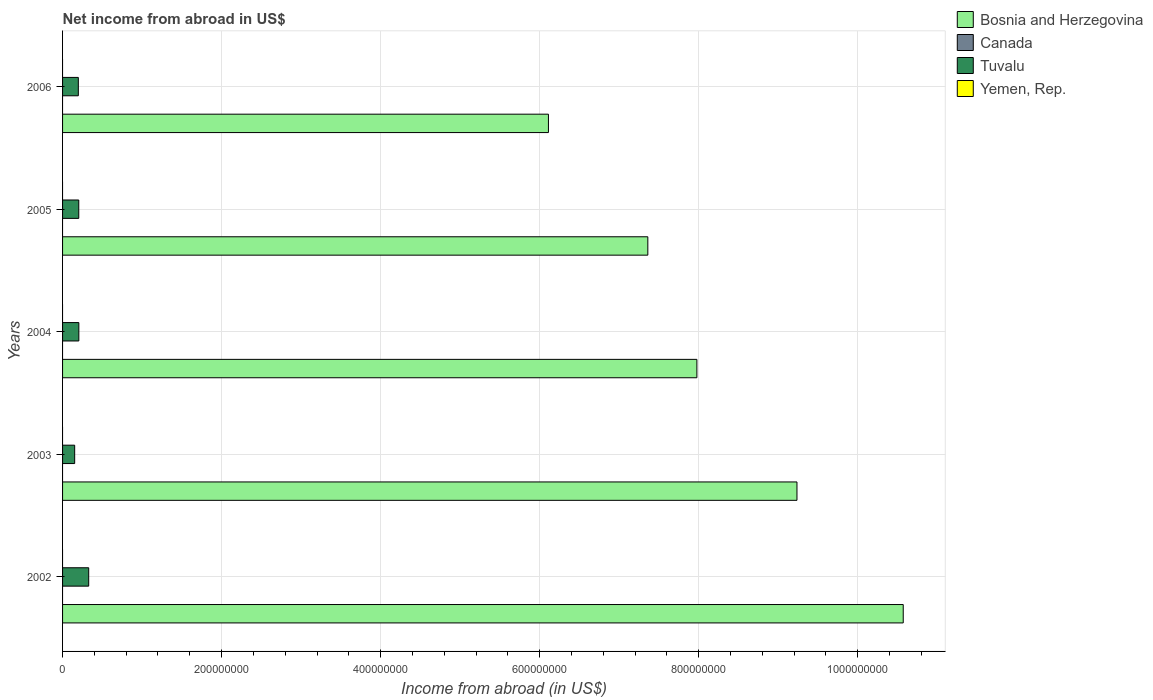How many different coloured bars are there?
Ensure brevity in your answer.  2. How many groups of bars are there?
Make the answer very short. 5. Are the number of bars per tick equal to the number of legend labels?
Your answer should be compact. No. Are the number of bars on each tick of the Y-axis equal?
Your answer should be compact. Yes. What is the label of the 3rd group of bars from the top?
Offer a very short reply. 2004. In how many cases, is the number of bars for a given year not equal to the number of legend labels?
Keep it short and to the point. 5. What is the net income from abroad in Bosnia and Herzegovina in 2003?
Provide a short and direct response. 9.24e+08. Across all years, what is the maximum net income from abroad in Bosnia and Herzegovina?
Make the answer very short. 1.06e+09. In which year was the net income from abroad in Tuvalu maximum?
Offer a terse response. 2002. What is the total net income from abroad in Canada in the graph?
Offer a terse response. 0. What is the difference between the net income from abroad in Tuvalu in 2003 and that in 2005?
Offer a very short reply. -5.15e+06. What is the difference between the net income from abroad in Tuvalu in 2006 and the net income from abroad in Bosnia and Herzegovina in 2003?
Provide a succinct answer. -9.04e+08. In the year 2002, what is the difference between the net income from abroad in Bosnia and Herzegovina and net income from abroad in Tuvalu?
Make the answer very short. 1.02e+09. In how many years, is the net income from abroad in Yemen, Rep. greater than 520000000 US$?
Ensure brevity in your answer.  0. What is the ratio of the net income from abroad in Tuvalu in 2002 to that in 2004?
Offer a terse response. 1.61. What is the difference between the highest and the second highest net income from abroad in Tuvalu?
Offer a terse response. 1.24e+07. What is the difference between the highest and the lowest net income from abroad in Tuvalu?
Offer a very short reply. 1.76e+07. In how many years, is the net income from abroad in Tuvalu greater than the average net income from abroad in Tuvalu taken over all years?
Offer a terse response. 1. How many bars are there?
Your answer should be compact. 10. Are all the bars in the graph horizontal?
Your answer should be compact. Yes. How many years are there in the graph?
Ensure brevity in your answer.  5. What is the difference between two consecutive major ticks on the X-axis?
Offer a terse response. 2.00e+08. How many legend labels are there?
Give a very brief answer. 4. How are the legend labels stacked?
Make the answer very short. Vertical. What is the title of the graph?
Provide a succinct answer. Net income from abroad in US$. What is the label or title of the X-axis?
Offer a terse response. Income from abroad (in US$). What is the label or title of the Y-axis?
Provide a short and direct response. Years. What is the Income from abroad (in US$) in Bosnia and Herzegovina in 2002?
Keep it short and to the point. 1.06e+09. What is the Income from abroad (in US$) in Canada in 2002?
Your answer should be compact. 0. What is the Income from abroad (in US$) of Tuvalu in 2002?
Offer a terse response. 3.29e+07. What is the Income from abroad (in US$) in Yemen, Rep. in 2002?
Offer a very short reply. 0. What is the Income from abroad (in US$) of Bosnia and Herzegovina in 2003?
Keep it short and to the point. 9.24e+08. What is the Income from abroad (in US$) of Tuvalu in 2003?
Offer a terse response. 1.52e+07. What is the Income from abroad (in US$) of Bosnia and Herzegovina in 2004?
Ensure brevity in your answer.  7.98e+08. What is the Income from abroad (in US$) in Tuvalu in 2004?
Make the answer very short. 2.05e+07. What is the Income from abroad (in US$) of Yemen, Rep. in 2004?
Keep it short and to the point. 0. What is the Income from abroad (in US$) in Bosnia and Herzegovina in 2005?
Give a very brief answer. 7.36e+08. What is the Income from abroad (in US$) of Canada in 2005?
Make the answer very short. 0. What is the Income from abroad (in US$) of Tuvalu in 2005?
Provide a succinct answer. 2.04e+07. What is the Income from abroad (in US$) of Yemen, Rep. in 2005?
Make the answer very short. 0. What is the Income from abroad (in US$) of Bosnia and Herzegovina in 2006?
Give a very brief answer. 6.11e+08. What is the Income from abroad (in US$) in Canada in 2006?
Give a very brief answer. 0. What is the Income from abroad (in US$) of Tuvalu in 2006?
Provide a short and direct response. 1.98e+07. What is the Income from abroad (in US$) of Yemen, Rep. in 2006?
Your answer should be very brief. 0. Across all years, what is the maximum Income from abroad (in US$) of Bosnia and Herzegovina?
Offer a terse response. 1.06e+09. Across all years, what is the maximum Income from abroad (in US$) of Tuvalu?
Keep it short and to the point. 3.29e+07. Across all years, what is the minimum Income from abroad (in US$) of Bosnia and Herzegovina?
Keep it short and to the point. 6.11e+08. Across all years, what is the minimum Income from abroad (in US$) of Tuvalu?
Keep it short and to the point. 1.52e+07. What is the total Income from abroad (in US$) of Bosnia and Herzegovina in the graph?
Make the answer very short. 4.13e+09. What is the total Income from abroad (in US$) of Tuvalu in the graph?
Offer a very short reply. 1.09e+08. What is the total Income from abroad (in US$) of Yemen, Rep. in the graph?
Your answer should be very brief. 0. What is the difference between the Income from abroad (in US$) in Bosnia and Herzegovina in 2002 and that in 2003?
Provide a succinct answer. 1.34e+08. What is the difference between the Income from abroad (in US$) in Tuvalu in 2002 and that in 2003?
Your answer should be very brief. 1.76e+07. What is the difference between the Income from abroad (in US$) in Bosnia and Herzegovina in 2002 and that in 2004?
Offer a terse response. 2.59e+08. What is the difference between the Income from abroad (in US$) in Tuvalu in 2002 and that in 2004?
Your answer should be very brief. 1.24e+07. What is the difference between the Income from abroad (in US$) of Bosnia and Herzegovina in 2002 and that in 2005?
Make the answer very short. 3.21e+08. What is the difference between the Income from abroad (in US$) in Tuvalu in 2002 and that in 2005?
Provide a succinct answer. 1.25e+07. What is the difference between the Income from abroad (in US$) of Bosnia and Herzegovina in 2002 and that in 2006?
Offer a terse response. 4.46e+08. What is the difference between the Income from abroad (in US$) of Tuvalu in 2002 and that in 2006?
Your response must be concise. 1.31e+07. What is the difference between the Income from abroad (in US$) in Bosnia and Herzegovina in 2003 and that in 2004?
Provide a short and direct response. 1.26e+08. What is the difference between the Income from abroad (in US$) in Tuvalu in 2003 and that in 2004?
Your answer should be compact. -5.24e+06. What is the difference between the Income from abroad (in US$) in Bosnia and Herzegovina in 2003 and that in 2005?
Offer a very short reply. 1.88e+08. What is the difference between the Income from abroad (in US$) of Tuvalu in 2003 and that in 2005?
Offer a terse response. -5.15e+06. What is the difference between the Income from abroad (in US$) in Bosnia and Herzegovina in 2003 and that in 2006?
Your answer should be very brief. 3.13e+08. What is the difference between the Income from abroad (in US$) of Tuvalu in 2003 and that in 2006?
Ensure brevity in your answer.  -4.59e+06. What is the difference between the Income from abroad (in US$) of Bosnia and Herzegovina in 2004 and that in 2005?
Make the answer very short. 6.17e+07. What is the difference between the Income from abroad (in US$) in Tuvalu in 2004 and that in 2005?
Provide a succinct answer. 9.28e+04. What is the difference between the Income from abroad (in US$) of Bosnia and Herzegovina in 2004 and that in 2006?
Ensure brevity in your answer.  1.87e+08. What is the difference between the Income from abroad (in US$) in Tuvalu in 2004 and that in 2006?
Your answer should be compact. 6.47e+05. What is the difference between the Income from abroad (in US$) of Bosnia and Herzegovina in 2005 and that in 2006?
Offer a terse response. 1.25e+08. What is the difference between the Income from abroad (in US$) of Tuvalu in 2005 and that in 2006?
Keep it short and to the point. 5.54e+05. What is the difference between the Income from abroad (in US$) in Bosnia and Herzegovina in 2002 and the Income from abroad (in US$) in Tuvalu in 2003?
Make the answer very short. 1.04e+09. What is the difference between the Income from abroad (in US$) of Bosnia and Herzegovina in 2002 and the Income from abroad (in US$) of Tuvalu in 2004?
Provide a succinct answer. 1.04e+09. What is the difference between the Income from abroad (in US$) of Bosnia and Herzegovina in 2002 and the Income from abroad (in US$) of Tuvalu in 2005?
Offer a terse response. 1.04e+09. What is the difference between the Income from abroad (in US$) in Bosnia and Herzegovina in 2002 and the Income from abroad (in US$) in Tuvalu in 2006?
Offer a terse response. 1.04e+09. What is the difference between the Income from abroad (in US$) in Bosnia and Herzegovina in 2003 and the Income from abroad (in US$) in Tuvalu in 2004?
Keep it short and to the point. 9.03e+08. What is the difference between the Income from abroad (in US$) of Bosnia and Herzegovina in 2003 and the Income from abroad (in US$) of Tuvalu in 2005?
Offer a terse response. 9.03e+08. What is the difference between the Income from abroad (in US$) in Bosnia and Herzegovina in 2003 and the Income from abroad (in US$) in Tuvalu in 2006?
Keep it short and to the point. 9.04e+08. What is the difference between the Income from abroad (in US$) in Bosnia and Herzegovina in 2004 and the Income from abroad (in US$) in Tuvalu in 2005?
Ensure brevity in your answer.  7.77e+08. What is the difference between the Income from abroad (in US$) of Bosnia and Herzegovina in 2004 and the Income from abroad (in US$) of Tuvalu in 2006?
Keep it short and to the point. 7.78e+08. What is the difference between the Income from abroad (in US$) of Bosnia and Herzegovina in 2005 and the Income from abroad (in US$) of Tuvalu in 2006?
Give a very brief answer. 7.16e+08. What is the average Income from abroad (in US$) of Bosnia and Herzegovina per year?
Ensure brevity in your answer.  8.25e+08. What is the average Income from abroad (in US$) of Tuvalu per year?
Give a very brief answer. 2.18e+07. In the year 2002, what is the difference between the Income from abroad (in US$) of Bosnia and Herzegovina and Income from abroad (in US$) of Tuvalu?
Offer a very short reply. 1.02e+09. In the year 2003, what is the difference between the Income from abroad (in US$) in Bosnia and Herzegovina and Income from abroad (in US$) in Tuvalu?
Give a very brief answer. 9.08e+08. In the year 2004, what is the difference between the Income from abroad (in US$) in Bosnia and Herzegovina and Income from abroad (in US$) in Tuvalu?
Your answer should be compact. 7.77e+08. In the year 2005, what is the difference between the Income from abroad (in US$) in Bosnia and Herzegovina and Income from abroad (in US$) in Tuvalu?
Your answer should be very brief. 7.16e+08. In the year 2006, what is the difference between the Income from abroad (in US$) of Bosnia and Herzegovina and Income from abroad (in US$) of Tuvalu?
Offer a very short reply. 5.91e+08. What is the ratio of the Income from abroad (in US$) of Bosnia and Herzegovina in 2002 to that in 2003?
Offer a very short reply. 1.14. What is the ratio of the Income from abroad (in US$) of Tuvalu in 2002 to that in 2003?
Give a very brief answer. 2.16. What is the ratio of the Income from abroad (in US$) in Bosnia and Herzegovina in 2002 to that in 2004?
Provide a short and direct response. 1.33. What is the ratio of the Income from abroad (in US$) in Tuvalu in 2002 to that in 2004?
Your answer should be very brief. 1.61. What is the ratio of the Income from abroad (in US$) in Bosnia and Herzegovina in 2002 to that in 2005?
Offer a very short reply. 1.44. What is the ratio of the Income from abroad (in US$) in Tuvalu in 2002 to that in 2005?
Offer a terse response. 1.61. What is the ratio of the Income from abroad (in US$) in Bosnia and Herzegovina in 2002 to that in 2006?
Your answer should be compact. 1.73. What is the ratio of the Income from abroad (in US$) of Tuvalu in 2002 to that in 2006?
Make the answer very short. 1.66. What is the ratio of the Income from abroad (in US$) in Bosnia and Herzegovina in 2003 to that in 2004?
Keep it short and to the point. 1.16. What is the ratio of the Income from abroad (in US$) in Tuvalu in 2003 to that in 2004?
Your response must be concise. 0.74. What is the ratio of the Income from abroad (in US$) in Bosnia and Herzegovina in 2003 to that in 2005?
Provide a short and direct response. 1.25. What is the ratio of the Income from abroad (in US$) of Tuvalu in 2003 to that in 2005?
Keep it short and to the point. 0.75. What is the ratio of the Income from abroad (in US$) of Bosnia and Herzegovina in 2003 to that in 2006?
Your answer should be compact. 1.51. What is the ratio of the Income from abroad (in US$) of Tuvalu in 2003 to that in 2006?
Offer a terse response. 0.77. What is the ratio of the Income from abroad (in US$) in Bosnia and Herzegovina in 2004 to that in 2005?
Offer a very short reply. 1.08. What is the ratio of the Income from abroad (in US$) in Bosnia and Herzegovina in 2004 to that in 2006?
Ensure brevity in your answer.  1.31. What is the ratio of the Income from abroad (in US$) in Tuvalu in 2004 to that in 2006?
Your answer should be very brief. 1.03. What is the ratio of the Income from abroad (in US$) of Bosnia and Herzegovina in 2005 to that in 2006?
Your response must be concise. 1.2. What is the ratio of the Income from abroad (in US$) in Tuvalu in 2005 to that in 2006?
Ensure brevity in your answer.  1.03. What is the difference between the highest and the second highest Income from abroad (in US$) in Bosnia and Herzegovina?
Your response must be concise. 1.34e+08. What is the difference between the highest and the second highest Income from abroad (in US$) of Tuvalu?
Provide a short and direct response. 1.24e+07. What is the difference between the highest and the lowest Income from abroad (in US$) of Bosnia and Herzegovina?
Keep it short and to the point. 4.46e+08. What is the difference between the highest and the lowest Income from abroad (in US$) in Tuvalu?
Keep it short and to the point. 1.76e+07. 